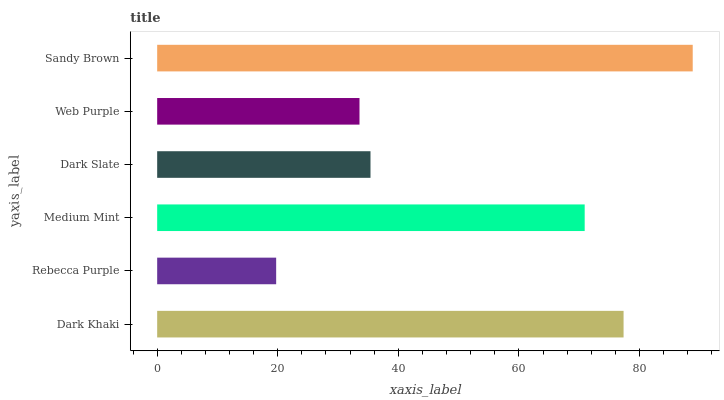Is Rebecca Purple the minimum?
Answer yes or no. Yes. Is Sandy Brown the maximum?
Answer yes or no. Yes. Is Medium Mint the minimum?
Answer yes or no. No. Is Medium Mint the maximum?
Answer yes or no. No. Is Medium Mint greater than Rebecca Purple?
Answer yes or no. Yes. Is Rebecca Purple less than Medium Mint?
Answer yes or no. Yes. Is Rebecca Purple greater than Medium Mint?
Answer yes or no. No. Is Medium Mint less than Rebecca Purple?
Answer yes or no. No. Is Medium Mint the high median?
Answer yes or no. Yes. Is Dark Slate the low median?
Answer yes or no. Yes. Is Rebecca Purple the high median?
Answer yes or no. No. Is Dark Khaki the low median?
Answer yes or no. No. 